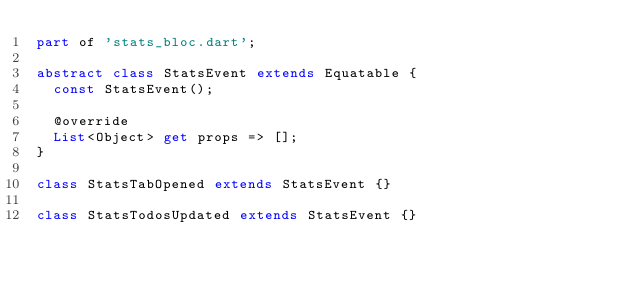Convert code to text. <code><loc_0><loc_0><loc_500><loc_500><_Dart_>part of 'stats_bloc.dart';

abstract class StatsEvent extends Equatable {
  const StatsEvent();

  @override
  List<Object> get props => [];
}

class StatsTabOpened extends StatsEvent {}

class StatsTodosUpdated extends StatsEvent {}
</code> 